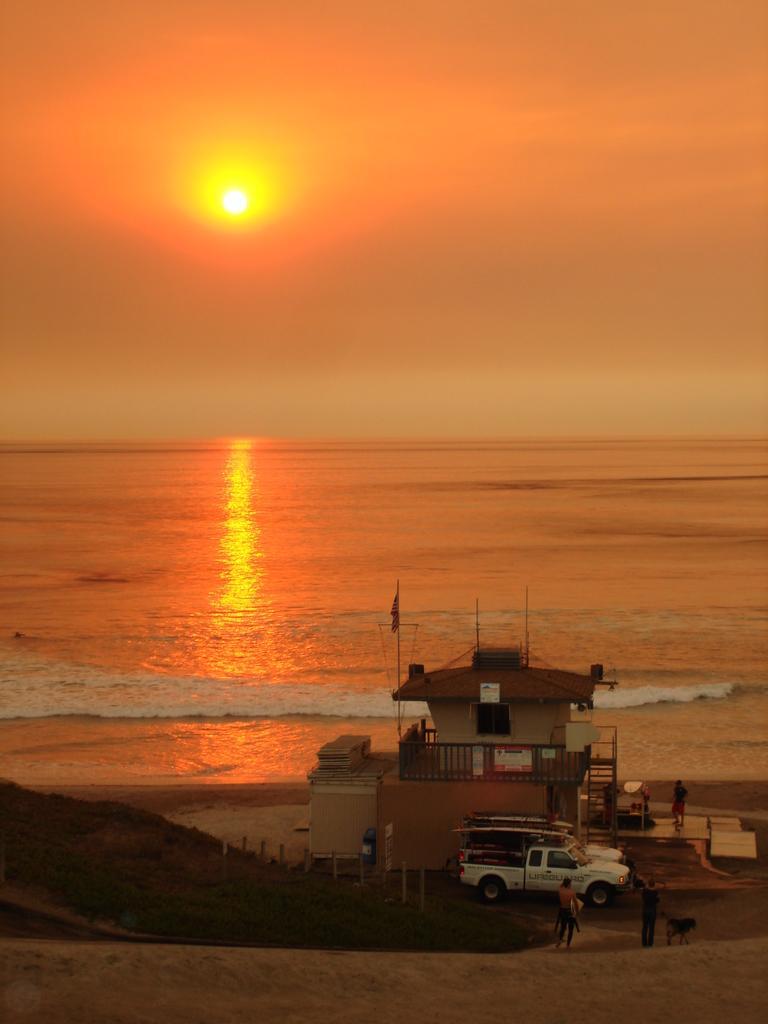Could you give a brief overview of what you see in this image? In this picture we can see some people on the path and a vehicle on the and behind the vehicle there is a house. Behind the house there is the sea and a sun in the sky 